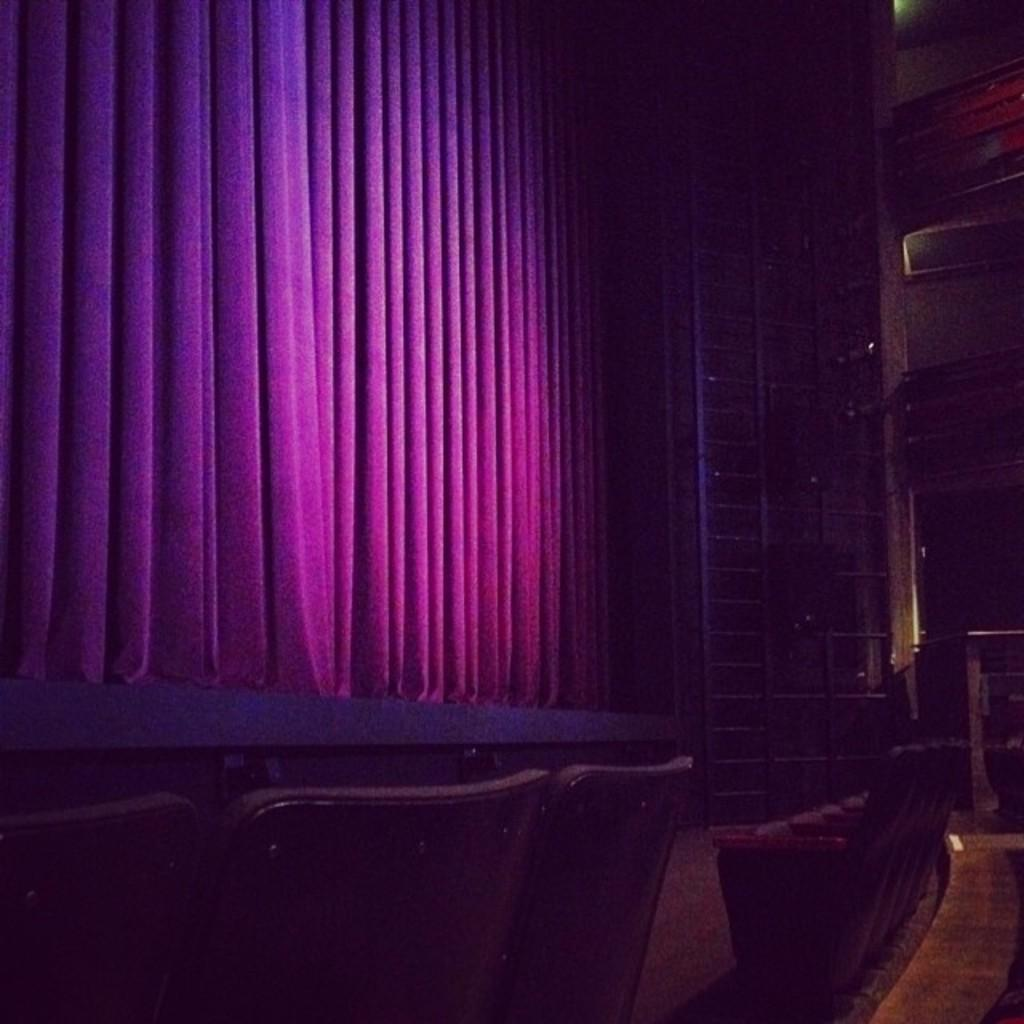What objects are in the foreground of the picture? There are chairs in the foreground of the picture. What is the main feature in the center of the picture? There is a stage in the center of the picture. What color is the curtain on the stage? The curtain on the stage is violet-colored. What can be seen on the right side of the picture? There is an iron frame, a wall, and a light on the right side of the picture. What advice is the person on stage giving to the audience in the image? There is no person on stage in the image, and therefore no advice can be given. What type of market is visible in the image? There is no market present in the image. 